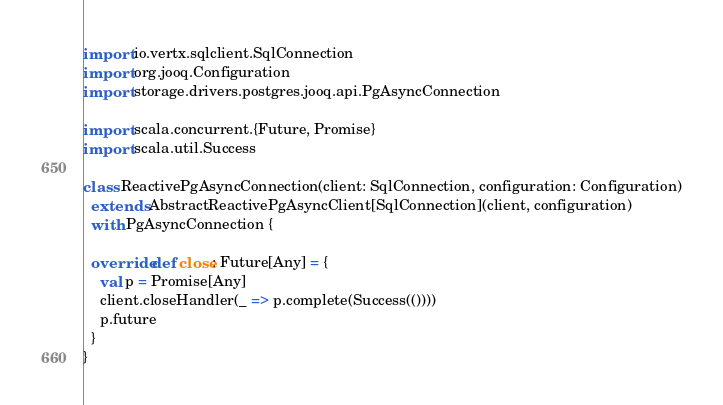<code> <loc_0><loc_0><loc_500><loc_500><_Scala_>
import io.vertx.sqlclient.SqlConnection
import org.jooq.Configuration
import storage.drivers.postgres.jooq.api.PgAsyncConnection

import scala.concurrent.{Future, Promise}
import scala.util.Success

class ReactivePgAsyncConnection(client: SqlConnection, configuration: Configuration)
  extends AbstractReactivePgAsyncClient[SqlConnection](client, configuration)
  with PgAsyncConnection {

  override def close: Future[Any] = {
    val p = Promise[Any]
    client.closeHandler(_ => p.complete(Success(())))
    p.future
  }
}
</code> 